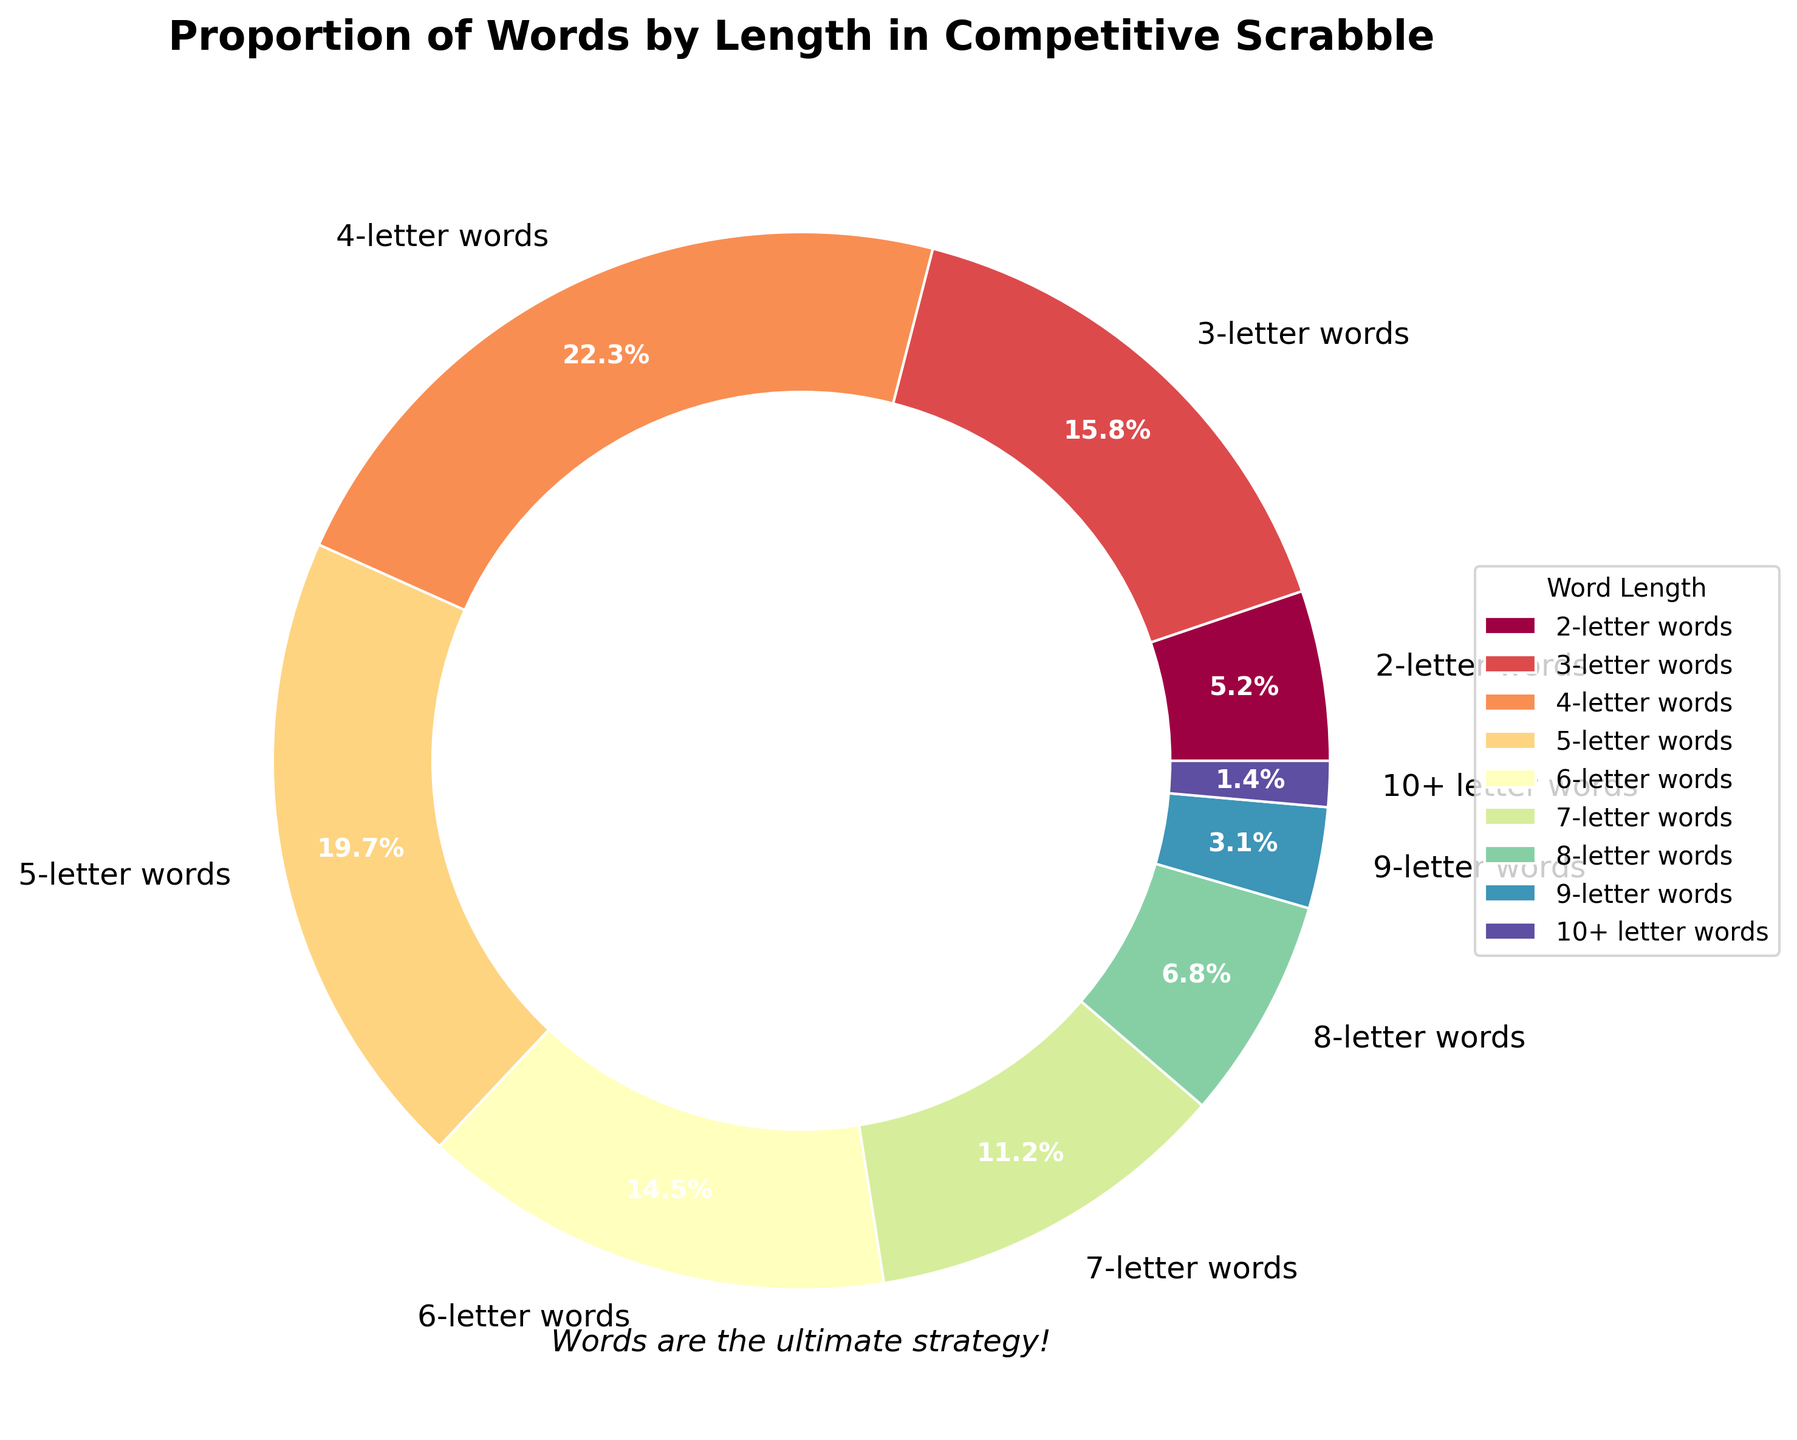What is the percentage of 5-letter words in the pie chart? The pie chart shows that 5-letter words account for 19.7% of the total words. This percentage is labeled directly on the pie segment for 5-letter words.
Answer: 19.7% Which length of words has the highest proportion? By looking at the pie chart, 4-letter words have the largest segment, and the label indicates that 4-letter words account for 22.3% of the total.
Answer: 4-letter words What's the combined percentage of 2-letter, 3-letter, and 4-letter words? Add the percentages of 2-letter words (5.2%), 3-letter words (15.8%), and 4-letter words (22.3%). 5.2 + 15.8 + 22.3 = 43.3%.
Answer: 43.3% Are there more 7-letter words or 6-letter words? Compare the percentages of 7-letter words (11.2%) with 6-letter words (14.5%). 14.5 is greater than 11.2.
Answer: 6-letter words What is the difference in percentage between 8-letter words and 9-letter words? Subtract the percentage of 9-letter words (3.1%) from 8-letter words (6.8%). 6.8 - 3.1 = 3.7%.
Answer: 3.7% What is the total percentage for words with a length of 7 letters or more? Add the percentages of 7-letter words (11.2%), 8-letter words (6.8%), 9-letter words (3.1%), and 10+ letter words (1.4%). 11.2 + 6.8 + 3.1 + 1.4 = 22.5%.
Answer: 22.5% Which word length is represented by the smallest segment in the pie chart? The chart indicates that 10+ letter words have the smallest segment, labeled as 1.4%.
Answer: 10+ letter words What is the average percentage of words with lengths 2, 3, and 10+? Add the percentages of 2-letter words (5.2%), 3-letter words (15.8%), and 10+ letter words (1.4%) and then divide by 3. (5.2 + 15.8 + 1.4)/3 ≈ 7.47%.
Answer: 7.47% How much larger is the proportion of 4-letter words compared to 9-letter words? Subtract the percentage of 9-letter words (3.1%) from 4-letter words (22.3%). 22.3 - 3.1 = 19.2%.
Answer: 19.2% 